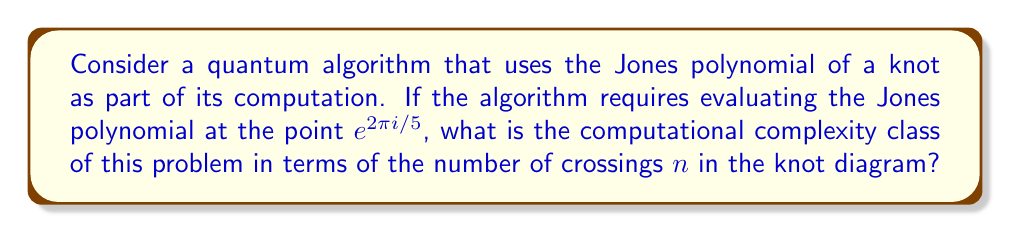Can you solve this math problem? To solve this problem, we need to follow these steps:

1) First, recall that the Jones polynomial is a knot invariant that can be used in certain quantum algorithms, particularly in topological quantum computation.

2) The evaluation of the Jones polynomial at specific roots of unity is known to have different computational complexities depending on the root.

3) For the point $e^{2\pi i/5}$, which is a 5th root of unity, the problem of evaluating the Jones polynomial falls into the complexity class BQP (Bounded-error Quantum Polynomial time).

4) BQP is the class of decision problems solvable by a quantum computer in polynomial time, with an error probability of at most 1/3 for all instances.

5) The time complexity of evaluating the Jones polynomial at $e^{2\pi i/5}$ using a quantum algorithm is $O(n^{c})$, where $n$ is the number of crossings in the knot diagram and $c$ is some constant.

6) This is in contrast to classical algorithms, which would require exponential time in the worst case.

7) Therefore, the computational complexity class for this problem is BQP, and the time complexity is polynomial in the number of crossings.
Answer: BQP, $O(n^c)$ 